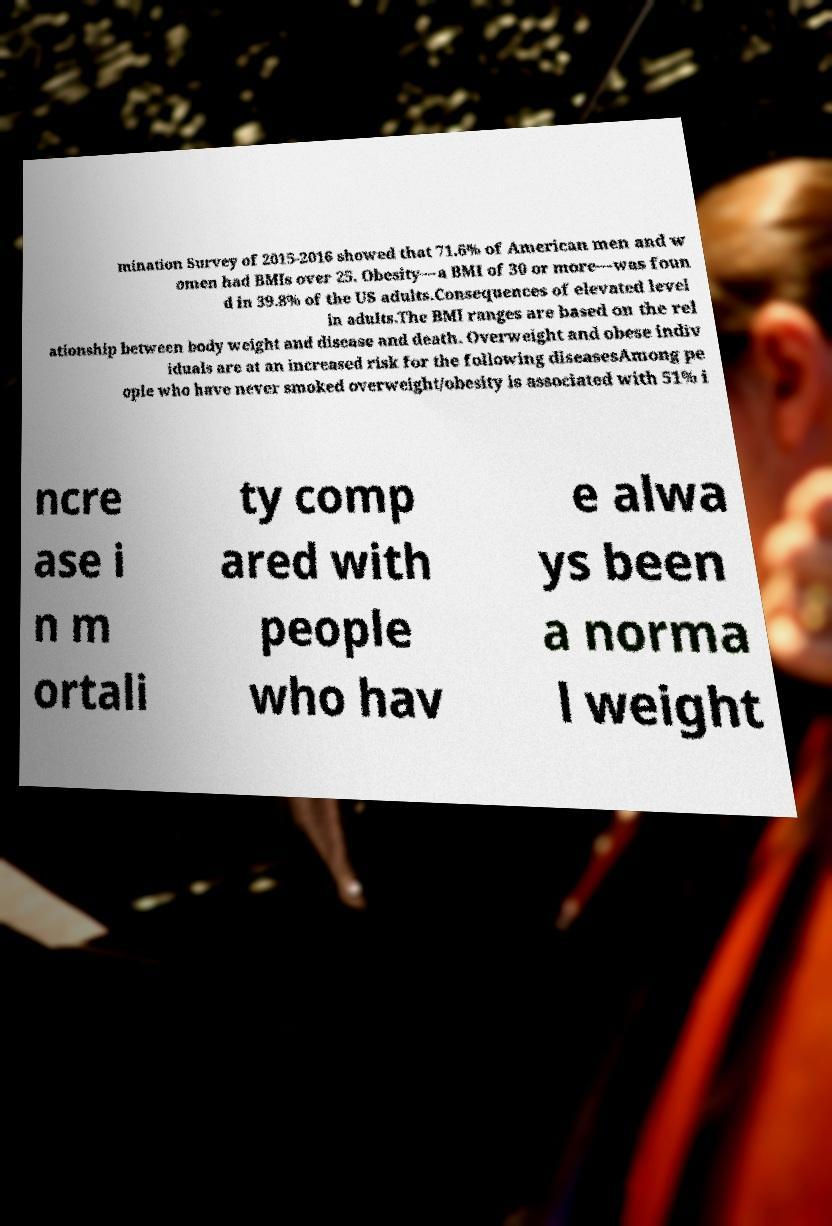Can you accurately transcribe the text from the provided image for me? mination Survey of 2015-2016 showed that 71.6% of American men and w omen had BMIs over 25. Obesity—a BMI of 30 or more—was foun d in 39.8% of the US adults.Consequences of elevated level in adults.The BMI ranges are based on the rel ationship between body weight and disease and death. Overweight and obese indiv iduals are at an increased risk for the following diseasesAmong pe ople who have never smoked overweight/obesity is associated with 51% i ncre ase i n m ortali ty comp ared with people who hav e alwa ys been a norma l weight 